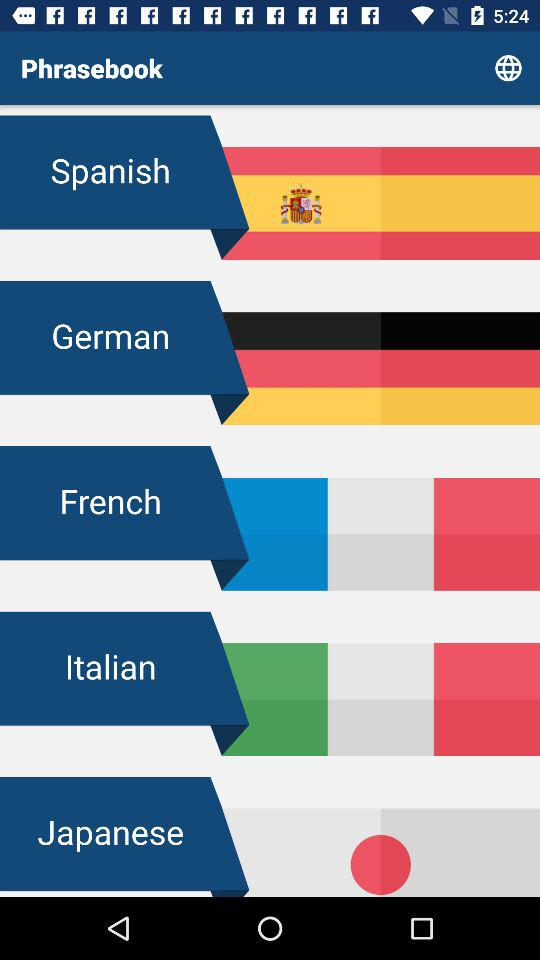How many languages are available in this phrasebook?
Answer the question using a single word or phrase. 5 